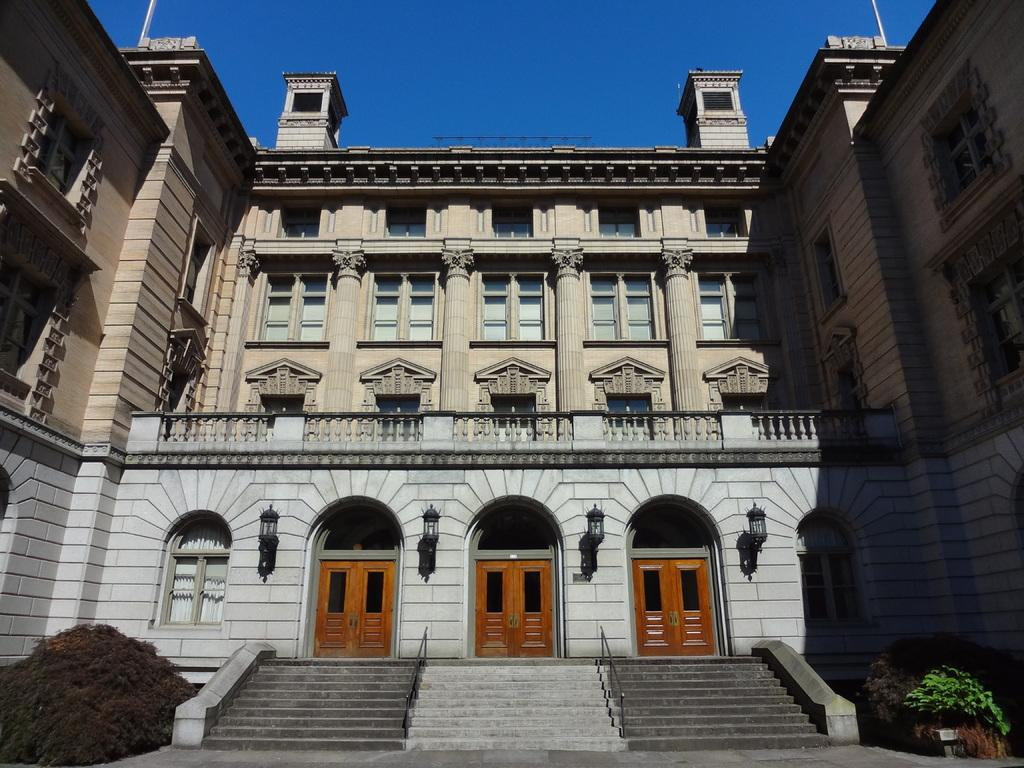What type of structure is in the image? There is a building in the image. What colors are present on the building? The building has gray and brown colors. How many doors are in front of the building? There are two brown doors in front of the building. What can be seen illuminated in the image? There are lights visible in the image. What type of vegetation is present in the image? There are plants with green color in the image. What is the color of the sky in the background? The sky in the background is blue. How long does it take for the stamp to reach the town in the image? There is no stamp or town present in the image, so this question cannot be answered. 